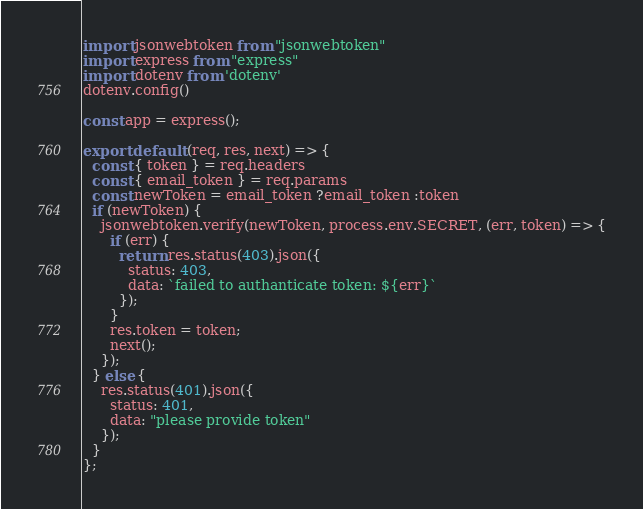Convert code to text. <code><loc_0><loc_0><loc_500><loc_500><_JavaScript_>import jsonwebtoken from "jsonwebtoken"
import express from "express"
import dotenv from 'dotenv'
dotenv.config()

const app = express();

export default (req, res, next) => {
  const { token } = req.headers
  const { email_token } = req.params
  const newToken = email_token ?email_token :token
  if (newToken) {
    jsonwebtoken.verify(newToken, process.env.SECRET, (err, token) => {
      if (err) {
        return res.status(403).json({
          status: 403,
          data: `failed to authanticate token: ${err}`
        });
      }
      res.token = token;
      next();
    });
  } else {
    res.status(401).json({
      status: 401,
      data: "please provide token"
    });
  }
};
</code> 